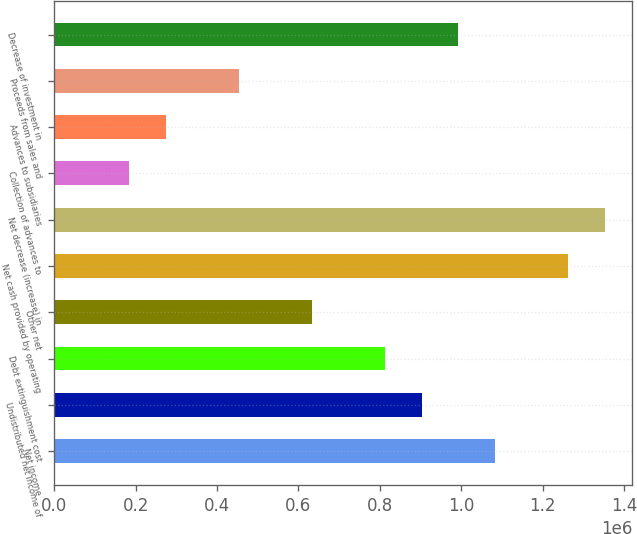Convert chart. <chart><loc_0><loc_0><loc_500><loc_500><bar_chart><fcel>Net income<fcel>Undistributed net income of<fcel>Debt extinguishment cost<fcel>Other net<fcel>Net cash provided by operating<fcel>Net decrease (increase) in<fcel>Collection of advances to<fcel>Advances to subsidiaries<fcel>Proceeds from sales and<fcel>Decrease of investment in<nl><fcel>1.08265e+06<fcel>903078<fcel>813290<fcel>633713<fcel>1.26223e+06<fcel>1.35202e+06<fcel>184772<fcel>274560<fcel>454136<fcel>992866<nl></chart> 